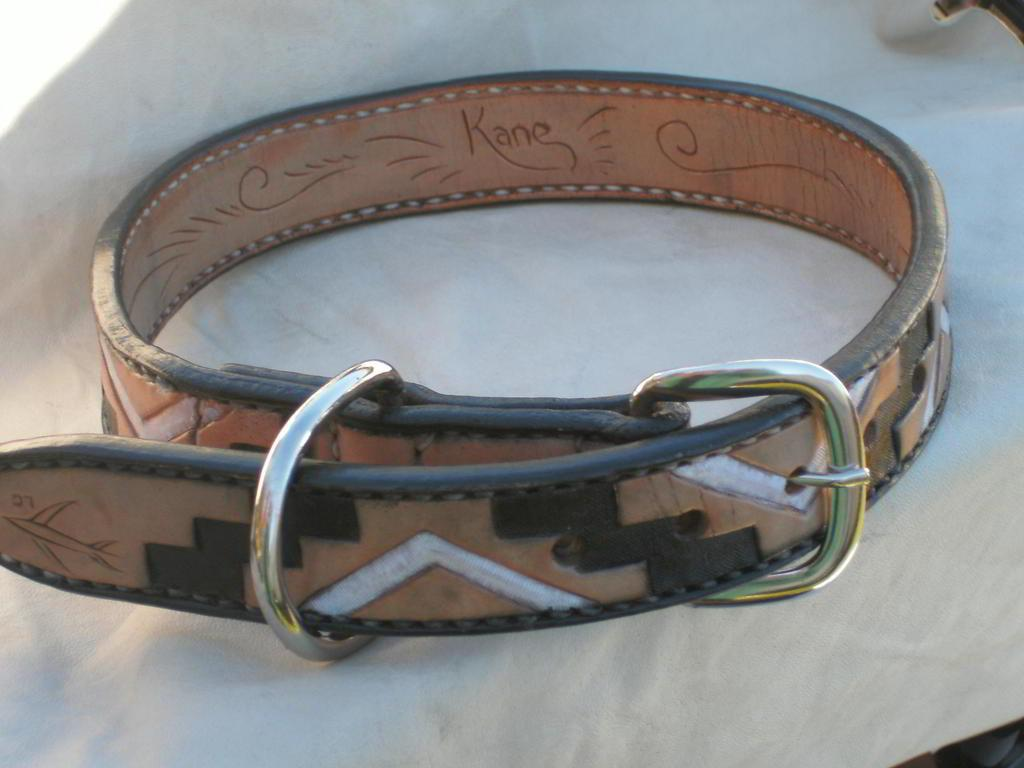<image>
Share a concise interpretation of the image provided. A leather wrist band with gold buckle and an engraving that says Kane. 